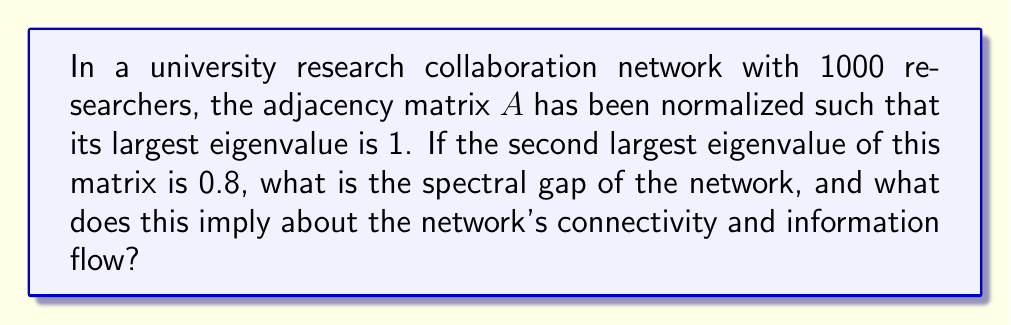Can you answer this question? To solve this problem, we need to follow these steps:

1. Understand the concept of spectral gap:
   The spectral gap is defined as the difference between the largest and second largest eigenvalues of the adjacency matrix. In mathematical notation:
   
   $$ \text{Spectral Gap} = \lambda_1 - \lambda_2 $$
   
   where $\lambda_1$ is the largest eigenvalue and $\lambda_2$ is the second largest eigenvalue.

2. Identify the given information:
   - The largest eigenvalue $\lambda_1 = 1$ (due to normalization)
   - The second largest eigenvalue $\lambda_2 = 0.8$

3. Calculate the spectral gap:
   $$ \text{Spectral Gap} = \lambda_1 - \lambda_2 = 1 - 0.8 = 0.2 $$

4. Interpret the result:
   - A smaller spectral gap (closer to 0) indicates a network with poor connectivity and slow information flow.
   - A larger spectral gap (closer to 1) indicates a network with good connectivity and fast information flow.
   - The spectral gap of 0.2 is relatively small, suggesting that:
     a) The network has moderately poor connectivity.
     b) Information flow across the network may be somewhat slow.
     c) The network might have distinct communities or clusters of researchers that are not well-connected to each other.

5. Implications for university research collaborations:
   - This spectral gap suggests that there might be silos or isolated groups within the research community.
   - Interdisciplinary collaboration may be limited.
   - There could be opportunities to improve research synergies by fostering more connections between different research groups or departments.
Answer: Spectral gap: 0.2. Implies moderately poor connectivity and relatively slow information flow in the research collaboration network. 